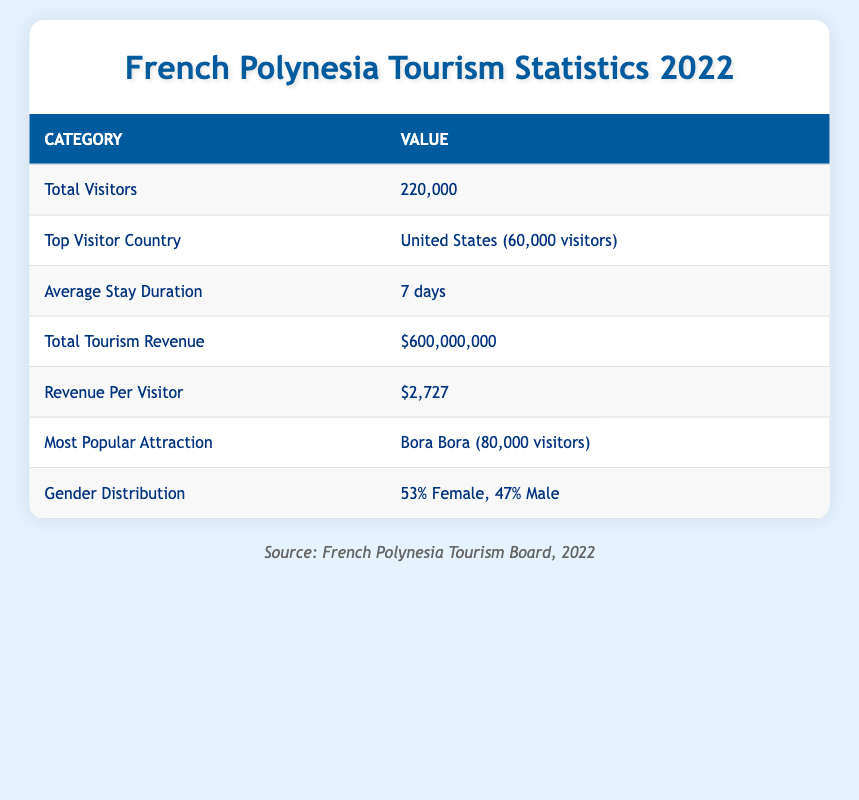What was the total number of visitors to French Polynesia in 2022? The table states that the total number of visitors was listed as 220,000.
Answer: 220,000 Which country contributed the highest number of visitors to French Polynesia? According to the table, the United States had the highest visitor count with 60,000 visitors.
Answer: United States What was the average stay duration for tourists in French Polynesia in 2022? The table indicates that the average stay duration was 7 days.
Answer: 7 days True or False: The total tourism revenue for French Polynesia in 2022 was less than $600 million. The table explicitly states that the total tourism revenue was $600,000,000, which means it is not less than that amount. Therefore, the statement is false.
Answer: False What percentage of visitors were female in 2022? The table provides the gender distribution, stating that 53% of visitors were female.
Answer: 53% If the average revenue per visitor is $2,727, what is the total revenue when multiplied by the total number of visitors? First, we take the total number of visitors (220,000) and multiply it by the revenue per visitor ($2,727). So, the calculation is 220,000 * 2,727 = 600,000,000. This confirms the total revenue listed in the table.
Answer: $600,000,000 What were the visitor counts for the top three attractions listed? The table shows that Bora Bora had 80,000 visitors, Moorea had 50,000 visitors, and Tahiti had 70,000 visitors. Therefore, combining these, we have: Bora Bora (80,000), Moorea (50,000), and Tahiti (70,000).
Answer: Bora Bora: 80,000, Moorea: 50,000, Tahiti: 70,000 How many more visitors did Bora Bora receive compared to New Zealand? The table lists Bora Bora with 80,000 visitors and New Zealand with 25,000 visitors. The difference can be calculated as 80,000 - 25,000 = 55,000 visitors more for Bora Bora.
Answer: 55,000 What is the ratio of female to male tourists based on the gender distribution? The table indicates 53% female and 47% male. To find the ratio, we can write it as 53:47. This is a simplified representation of the data.
Answer: 53:47 